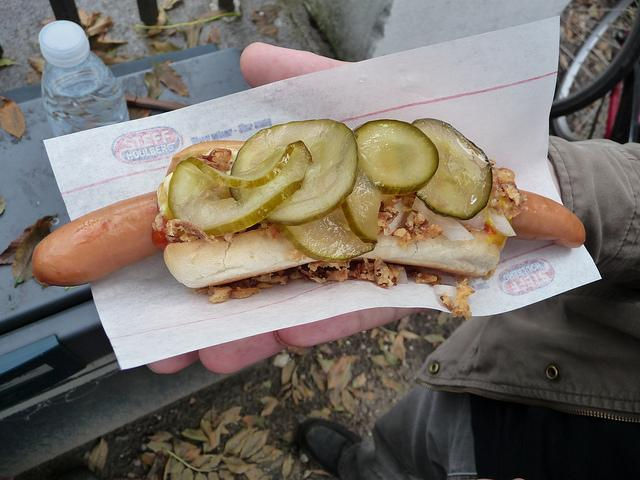What type of solution were the cucumbers soaked in?

Choices:
A) yogurt
B) mustard
C) syrup
D) brine brine 